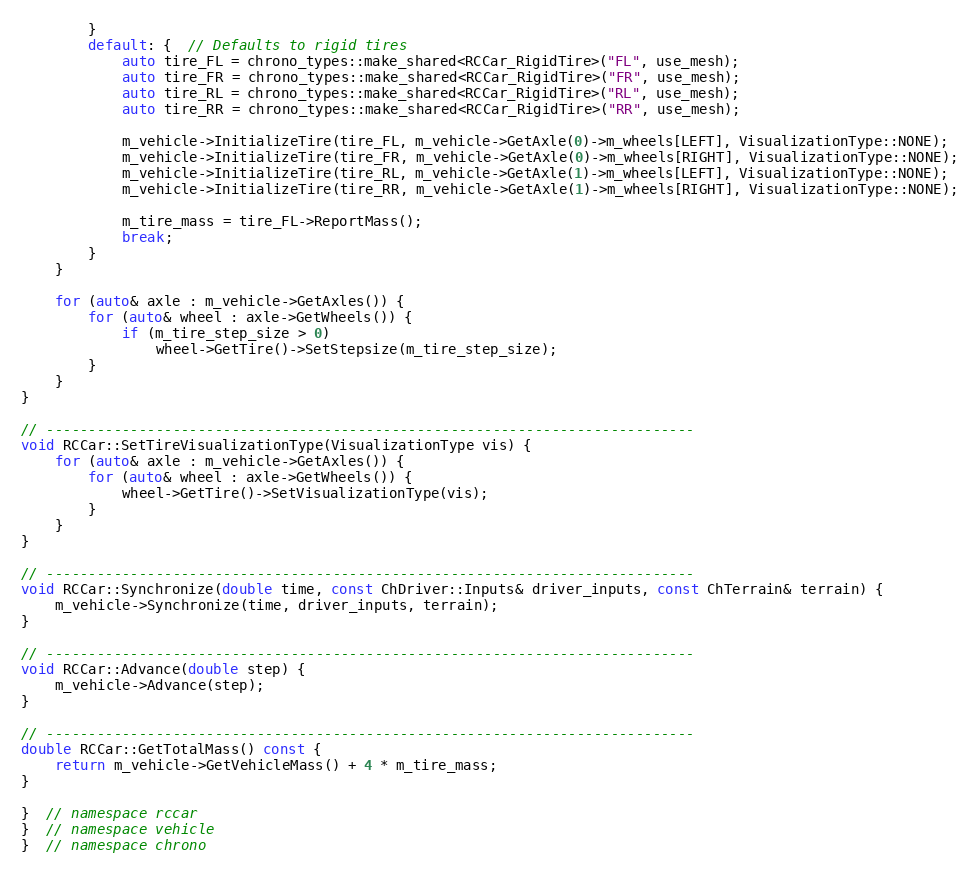<code> <loc_0><loc_0><loc_500><loc_500><_C++_>        }
        default: {  // Defaults to rigid tires
            auto tire_FL = chrono_types::make_shared<RCCar_RigidTire>("FL", use_mesh);
            auto tire_FR = chrono_types::make_shared<RCCar_RigidTire>("FR", use_mesh);
            auto tire_RL = chrono_types::make_shared<RCCar_RigidTire>("RL", use_mesh);
            auto tire_RR = chrono_types::make_shared<RCCar_RigidTire>("RR", use_mesh);

            m_vehicle->InitializeTire(tire_FL, m_vehicle->GetAxle(0)->m_wheels[LEFT], VisualizationType::NONE);
            m_vehicle->InitializeTire(tire_FR, m_vehicle->GetAxle(0)->m_wheels[RIGHT], VisualizationType::NONE);
            m_vehicle->InitializeTire(tire_RL, m_vehicle->GetAxle(1)->m_wheels[LEFT], VisualizationType::NONE);
            m_vehicle->InitializeTire(tire_RR, m_vehicle->GetAxle(1)->m_wheels[RIGHT], VisualizationType::NONE);

            m_tire_mass = tire_FL->ReportMass();
            break;
        }
    }

    for (auto& axle : m_vehicle->GetAxles()) {
        for (auto& wheel : axle->GetWheels()) {
            if (m_tire_step_size > 0)
                wheel->GetTire()->SetStepsize(m_tire_step_size);
        }
    }
}

// -----------------------------------------------------------------------------
void RCCar::SetTireVisualizationType(VisualizationType vis) {
    for (auto& axle : m_vehicle->GetAxles()) {
        for (auto& wheel : axle->GetWheels()) {
            wheel->GetTire()->SetVisualizationType(vis);
        }
    }
}

// -----------------------------------------------------------------------------
void RCCar::Synchronize(double time, const ChDriver::Inputs& driver_inputs, const ChTerrain& terrain) {
    m_vehicle->Synchronize(time, driver_inputs, terrain);
}

// -----------------------------------------------------------------------------
void RCCar::Advance(double step) {
    m_vehicle->Advance(step);
}

// -----------------------------------------------------------------------------
double RCCar::GetTotalMass() const {
    return m_vehicle->GetVehicleMass() + 4 * m_tire_mass;
}

}  // namespace rccar
}  // namespace vehicle
}  // namespace chrono
</code> 